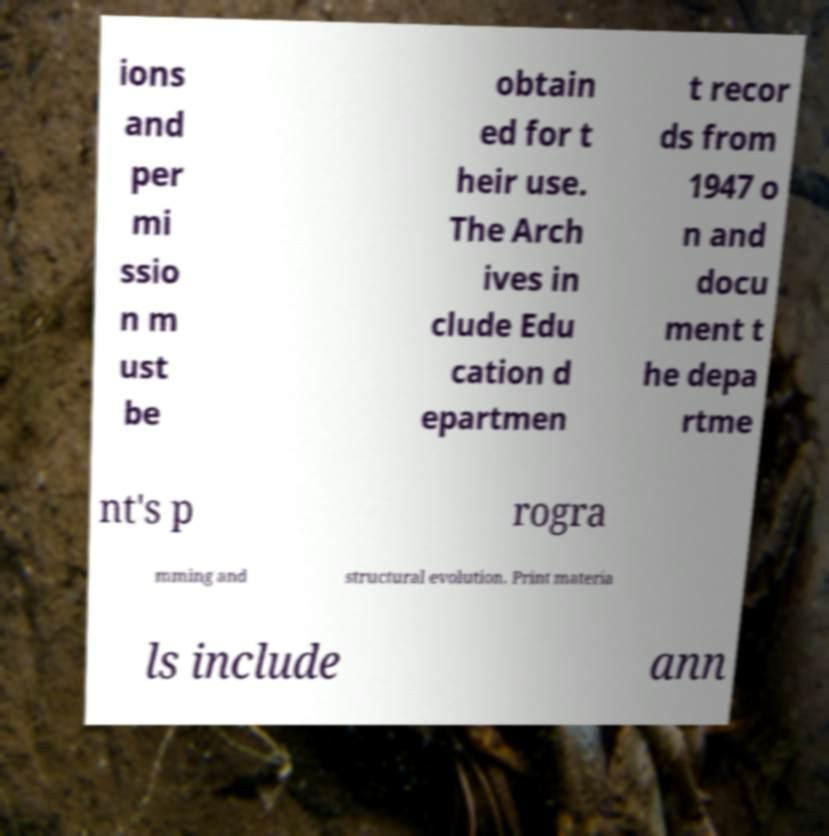I need the written content from this picture converted into text. Can you do that? ions and per mi ssio n m ust be obtain ed for t heir use. The Arch ives in clude Edu cation d epartmen t recor ds from 1947 o n and docu ment t he depa rtme nt's p rogra mming and structural evolution. Print materia ls include ann 